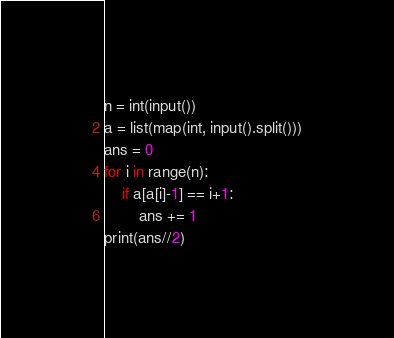Convert code to text. <code><loc_0><loc_0><loc_500><loc_500><_Python_>n = int(input())
a = list(map(int, input().split()))
ans = 0
for i in range(n):
    if a[a[i]-1] == i+1:
        ans += 1
print(ans//2)</code> 